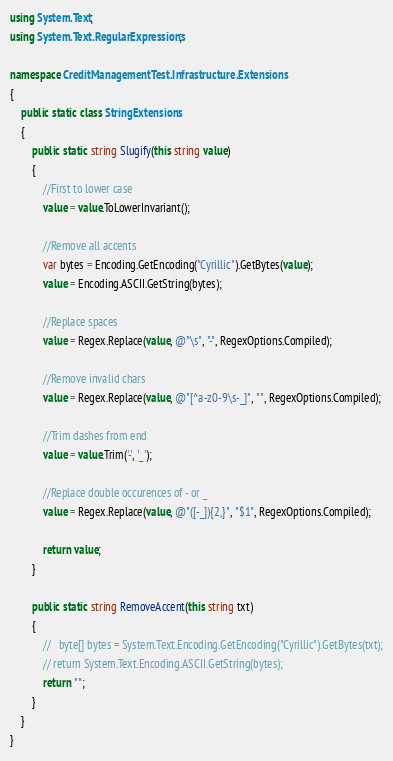<code> <loc_0><loc_0><loc_500><loc_500><_C#_>using System.Text;
using System.Text.RegularExpressions;

namespace CreditManagementTest.Infrastructure.Extensions
{
    public static class StringExtensions
    {
        public static string Slugify(this string value)
        {
            //First to lower case
            value = value.ToLowerInvariant();

            //Remove all accents
            var bytes = Encoding.GetEncoding("Cyrillic").GetBytes(value);
            value = Encoding.ASCII.GetString(bytes);

            //Replace spaces
            value = Regex.Replace(value, @"\s", "-", RegexOptions.Compiled);

            //Remove invalid chars
            value = Regex.Replace(value, @"[^a-z0-9\s-_]", "", RegexOptions.Compiled);

            //Trim dashes from end
            value = value.Trim('-', '_');

            //Replace double occurences of - or _
            value = Regex.Replace(value, @"([-_]){2,}", "$1", RegexOptions.Compiled);

            return value;
        }

        public static string RemoveAccent(this string txt)
        {
            //   byte[] bytes = System.Text.Encoding.GetEncoding("Cyrillic").GetBytes(txt);
            // return System.Text.Encoding.ASCII.GetString(bytes);
            return "";
        }
    }
}</code> 